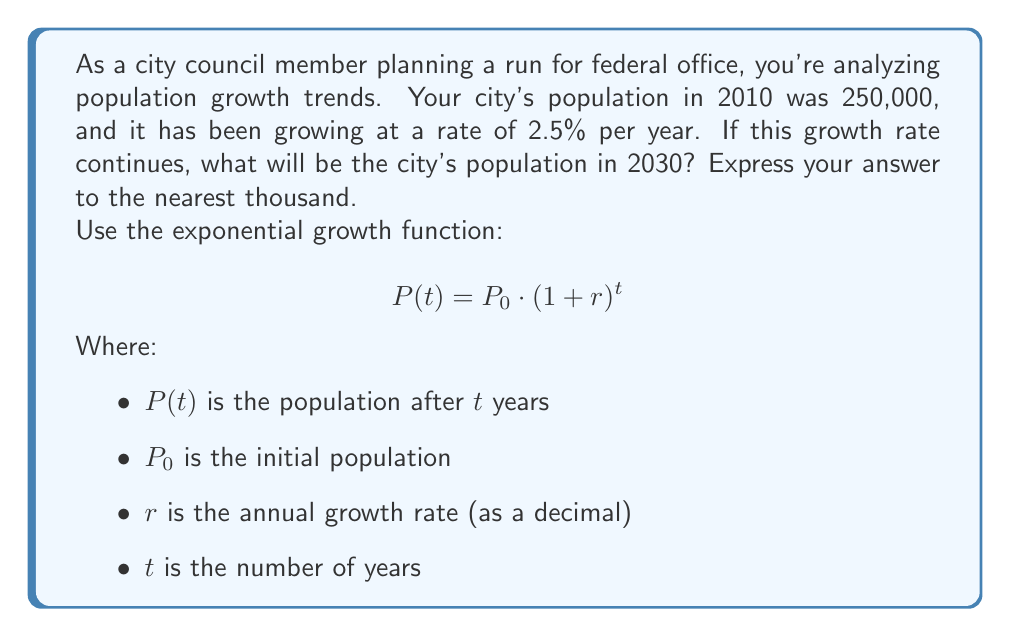Teach me how to tackle this problem. Let's approach this step-by-step:

1) We're given:
   $P_0 = 250,000$ (initial population in 2010)
   $r = 0.025$ (2.5% expressed as a decimal)
   $t = 20$ (number of years from 2010 to 2030)

2) We'll use the exponential growth function:
   $$P(t) = P_0 \cdot (1 + r)^t$$

3) Substituting our values:
   $$P(20) = 250,000 \cdot (1 + 0.025)^{20}$$

4) Let's calculate $(1 + 0.025)^{20}$ first:
   $$(1.025)^{20} \approx 1.6386$$

5) Now we can complete the calculation:
   $$P(20) = 250,000 \cdot 1.6386 = 409,650$$

6) Rounding to the nearest thousand:
   $$P(20) \approx 410,000$$

This result shows that if the current growth rate continues, the city's population will increase by about 160,000 people over 20 years, which is significant information for urban planning and resource allocation at both the local and federal levels.
Answer: 410,000 